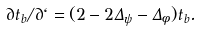Convert formula to latex. <formula><loc_0><loc_0><loc_500><loc_500>\partial t _ { b } / \partial \ell = ( 2 - 2 \Delta _ { \psi } - \Delta _ { \phi } ) t _ { b } .</formula> 